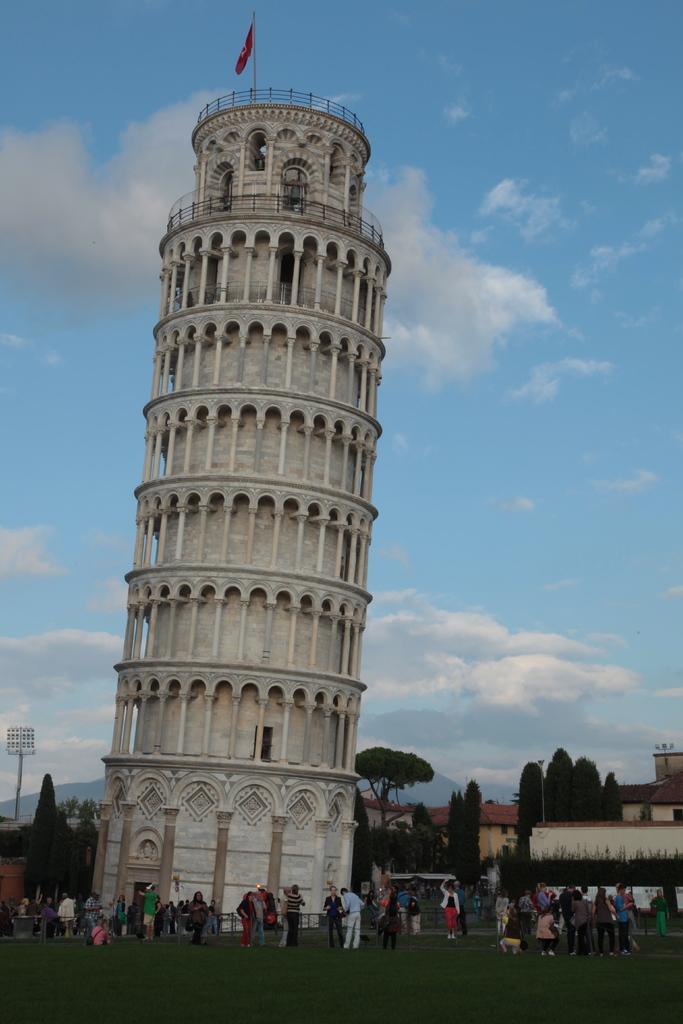Please provide a concise description of this image. In this image I can see leaning tower of Pisa. I can see few trees. There are some people in the ground. In the background I can see clouds in the sky. 